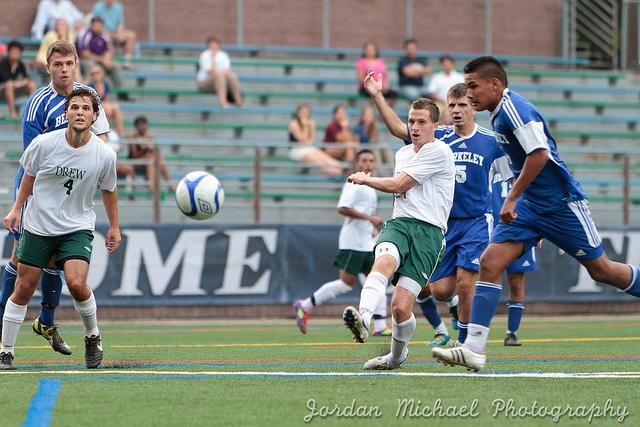What sport is shown?
Short answer required. Soccer. Are the men enjoying the game?
Be succinct. Yes. Is the ball in motion?
Be succinct. Yes. Are all the players on the same team?
Concise answer only. No. What sport are they playing?
Give a very brief answer. Soccer. Are all the lines the same thickness?
Concise answer only. Yes. 